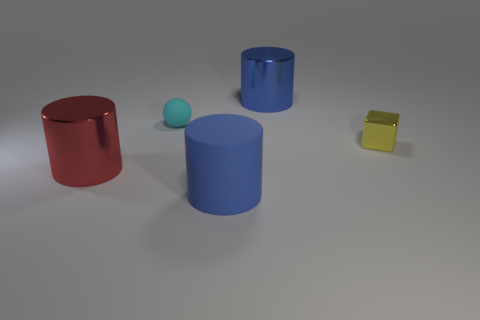Is the number of blue shiny objects behind the tiny cyan sphere greater than the number of big rubber things that are on the left side of the blue rubber thing? Yes, indeed! Behind the tiny cyan sphere, we can see two blue shiny objects. In comparison, on the left side of the blue rubber thing, there doesn't appear to be any big rubber object. So, the number of blue shiny objects behind the cyan sphere is certainly greater, since it is two compared to zero. 